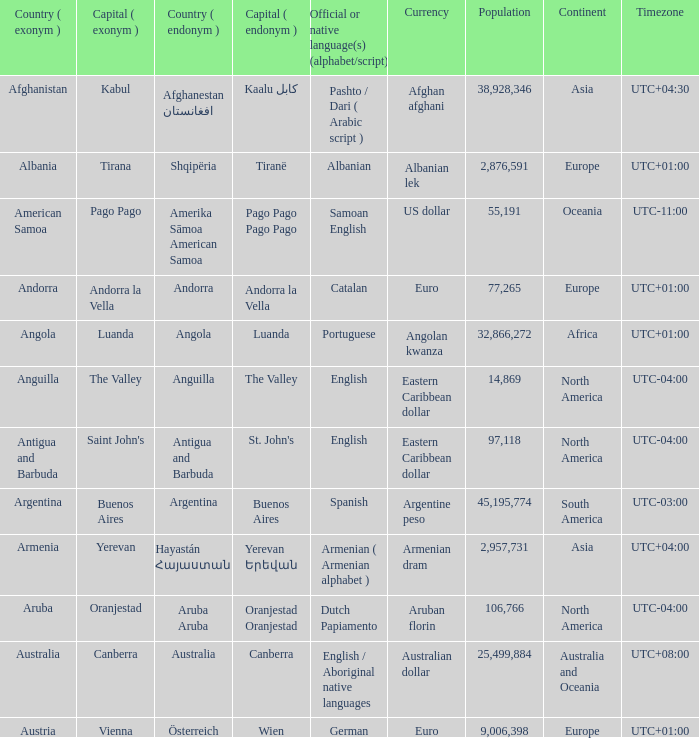Parse the table in full. {'header': ['Country ( exonym )', 'Capital ( exonym )', 'Country ( endonym )', 'Capital ( endonym )', 'Official or native language(s) (alphabet/script)', 'Currency', 'Population', 'Continent', 'Timezone'], 'rows': [['Afghanistan', 'Kabul', 'Afghanestan افغانستان', 'Kaalu كابل', 'Pashto / Dari ( Arabic script )', 'Afghan afghani', '38,928,346', 'Asia', 'UTC+04:30'], ['Albania', 'Tirana', 'Shqipëria', 'Tiranë', 'Albanian', 'Albanian lek', '2,876,591', 'Europe', 'UTC+01:00'], ['American Samoa', 'Pago Pago', 'Amerika Sāmoa American Samoa', 'Pago Pago Pago Pago', 'Samoan English', 'US dollar', '55,191', 'Oceania', 'UTC-11:00'], ['Andorra', 'Andorra la Vella', 'Andorra', 'Andorra la Vella', 'Catalan', 'Euro', '77,265', 'Europe', 'UTC+01:00'], ['Angola', 'Luanda', 'Angola', 'Luanda', 'Portuguese', 'Angolan kwanza', '32,866,272', 'Africa', 'UTC+01:00'], ['Anguilla', 'The Valley', 'Anguilla', 'The Valley', 'English', 'Eastern Caribbean dollar', '14,869', 'North America', 'UTC-04:00'], ['Antigua and Barbuda', "Saint John's", 'Antigua and Barbuda', "St. John's", 'English', 'Eastern Caribbean dollar', '97,118', 'North America', 'UTC-04:00'], ['Argentina', 'Buenos Aires', 'Argentina', 'Buenos Aires', 'Spanish', 'Argentine peso', '45,195,774', 'South America', 'UTC-03:00'], ['Armenia', 'Yerevan', 'Hayastán Հայաստան', 'Yerevan Երեվան', 'Armenian ( Armenian alphabet )', 'Armenian dram', '2,957,731', 'Asia', 'UTC+04:00'], ['Aruba', 'Oranjestad', 'Aruba Aruba', 'Oranjestad Oranjestad', 'Dutch Papiamento', 'Aruban florin', '106,766', 'North America', 'UTC-04:00'], ['Australia', 'Canberra', 'Australia', 'Canberra', 'English / Aboriginal native languages', 'Australian dollar', '25,499,884', 'Australia and Oceania', 'UTC+08:00'], ['Austria', 'Vienna', 'Österreich', 'Wien', 'German', 'Euro', '9,006,398', 'Europe', 'UTC+01:00']]} How many capital cities does Australia have? 1.0. 